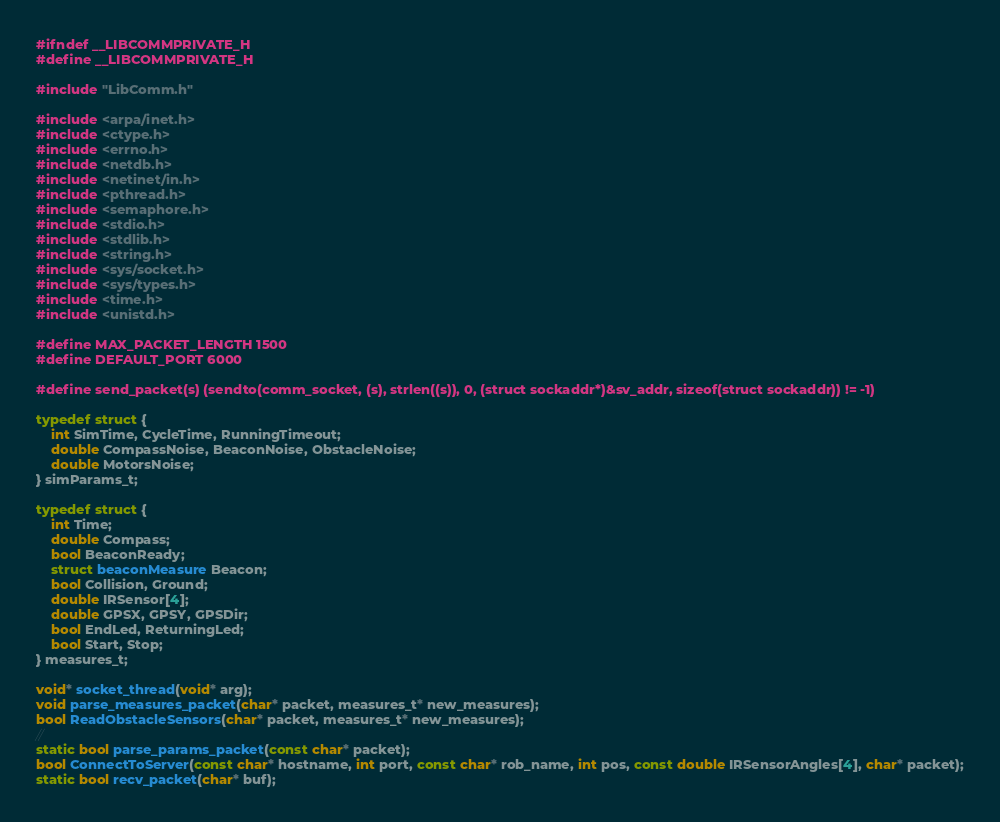Convert code to text. <code><loc_0><loc_0><loc_500><loc_500><_C_>#ifndef __LIBCOMMPRIVATE_H
#define __LIBCOMMPRIVATE_H

#include "LibComm.h"

#include <arpa/inet.h>
#include <ctype.h>
#include <errno.h>
#include <netdb.h>
#include <netinet/in.h>
#include <pthread.h>
#include <semaphore.h>
#include <stdio.h>
#include <stdlib.h>
#include <string.h>
#include <sys/socket.h>
#include <sys/types.h>
#include <time.h>
#include <unistd.h>

#define MAX_PACKET_LENGTH 1500
#define DEFAULT_PORT 6000

#define send_packet(s) (sendto(comm_socket, (s), strlen((s)), 0, (struct sockaddr*)&sv_addr, sizeof(struct sockaddr)) != -1)

typedef struct {
    int SimTime, CycleTime, RunningTimeout;
    double CompassNoise, BeaconNoise, ObstacleNoise;
    double MotorsNoise;
} simParams_t;

typedef struct {
    int Time;
    double Compass;
    bool BeaconReady;
    struct beaconMeasure Beacon;
    bool Collision, Ground;
    double IRSensor[4];
    double GPSX, GPSY, GPSDir;
    bool EndLed, ReturningLed;
    bool Start, Stop;
} measures_t;

void* socket_thread(void* arg);
void parse_measures_packet(char* packet, measures_t* new_measures);
bool ReadObstacleSensors(char* packet, measures_t* new_measures);
//
static bool parse_params_packet(const char* packet);
bool ConnectToServer(const char* hostname, int port, const char* rob_name, int pos, const double IRSensorAngles[4], char* packet);
static bool recv_packet(char* buf);</code> 